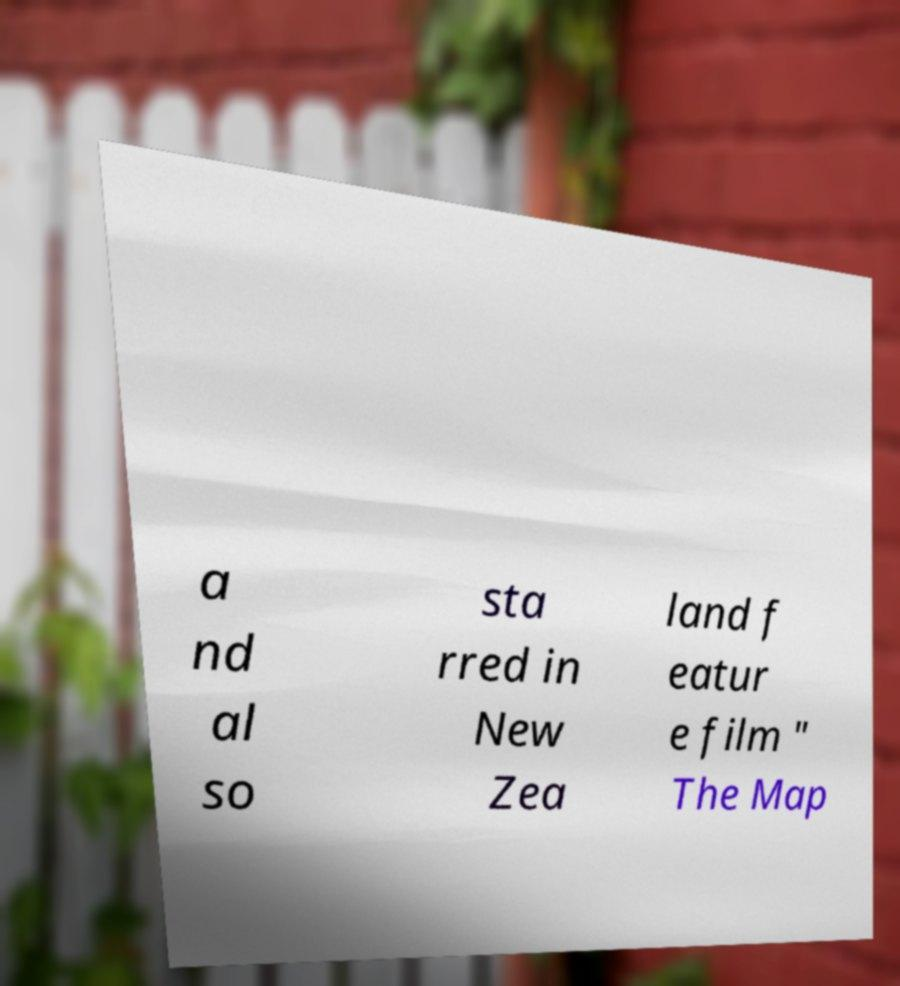Can you read and provide the text displayed in the image?This photo seems to have some interesting text. Can you extract and type it out for me? a nd al so sta rred in New Zea land f eatur e film " The Map 